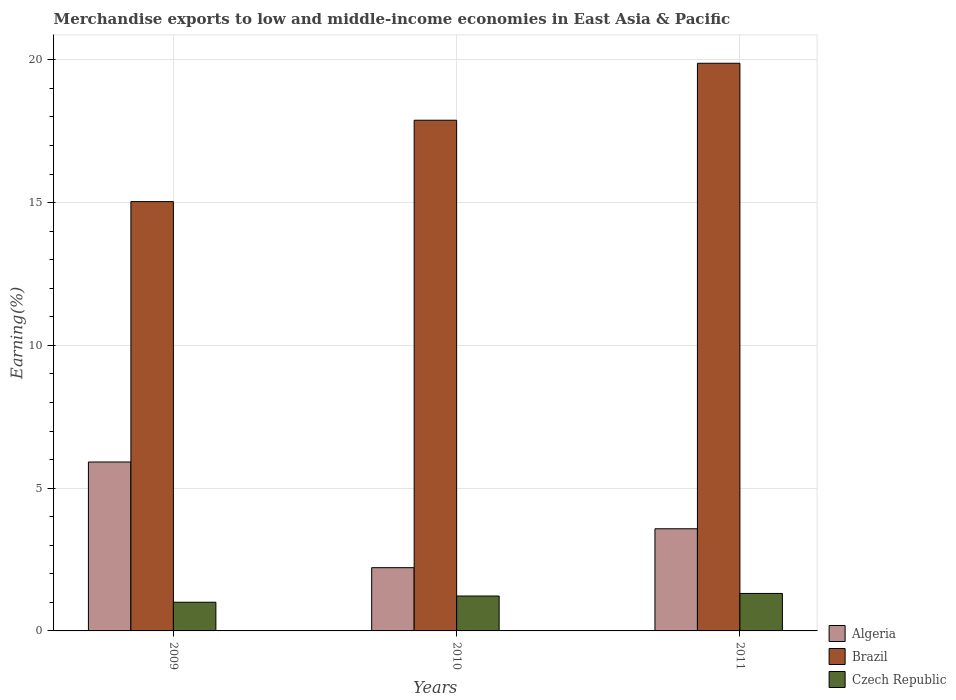How many different coloured bars are there?
Provide a succinct answer. 3. How many groups of bars are there?
Your answer should be compact. 3. Are the number of bars per tick equal to the number of legend labels?
Your answer should be compact. Yes. How many bars are there on the 2nd tick from the left?
Offer a very short reply. 3. How many bars are there on the 3rd tick from the right?
Your answer should be compact. 3. What is the label of the 1st group of bars from the left?
Keep it short and to the point. 2009. What is the percentage of amount earned from merchandise exports in Brazil in 2011?
Give a very brief answer. 19.88. Across all years, what is the maximum percentage of amount earned from merchandise exports in Algeria?
Your response must be concise. 5.92. Across all years, what is the minimum percentage of amount earned from merchandise exports in Czech Republic?
Your response must be concise. 1. In which year was the percentage of amount earned from merchandise exports in Czech Republic minimum?
Provide a succinct answer. 2009. What is the total percentage of amount earned from merchandise exports in Brazil in the graph?
Make the answer very short. 52.8. What is the difference between the percentage of amount earned from merchandise exports in Brazil in 2009 and that in 2010?
Your response must be concise. -2.85. What is the difference between the percentage of amount earned from merchandise exports in Brazil in 2011 and the percentage of amount earned from merchandise exports in Czech Republic in 2010?
Your response must be concise. 18.66. What is the average percentage of amount earned from merchandise exports in Brazil per year?
Your answer should be very brief. 17.6. In the year 2009, what is the difference between the percentage of amount earned from merchandise exports in Czech Republic and percentage of amount earned from merchandise exports in Brazil?
Keep it short and to the point. -14.03. In how many years, is the percentage of amount earned from merchandise exports in Czech Republic greater than 9 %?
Ensure brevity in your answer.  0. What is the ratio of the percentage of amount earned from merchandise exports in Czech Republic in 2009 to that in 2011?
Make the answer very short. 0.77. Is the percentage of amount earned from merchandise exports in Czech Republic in 2009 less than that in 2010?
Your response must be concise. Yes. Is the difference between the percentage of amount earned from merchandise exports in Czech Republic in 2009 and 2011 greater than the difference between the percentage of amount earned from merchandise exports in Brazil in 2009 and 2011?
Offer a very short reply. Yes. What is the difference between the highest and the second highest percentage of amount earned from merchandise exports in Czech Republic?
Ensure brevity in your answer.  0.09. What is the difference between the highest and the lowest percentage of amount earned from merchandise exports in Algeria?
Offer a very short reply. 3.7. What does the 2nd bar from the left in 2009 represents?
Keep it short and to the point. Brazil. What does the 3rd bar from the right in 2010 represents?
Give a very brief answer. Algeria. How many bars are there?
Give a very brief answer. 9. How many years are there in the graph?
Offer a terse response. 3. What is the difference between two consecutive major ticks on the Y-axis?
Keep it short and to the point. 5. Are the values on the major ticks of Y-axis written in scientific E-notation?
Your response must be concise. No. Does the graph contain grids?
Give a very brief answer. Yes. How many legend labels are there?
Your answer should be very brief. 3. What is the title of the graph?
Provide a succinct answer. Merchandise exports to low and middle-income economies in East Asia & Pacific. What is the label or title of the Y-axis?
Make the answer very short. Earning(%). What is the Earning(%) of Algeria in 2009?
Offer a terse response. 5.92. What is the Earning(%) in Brazil in 2009?
Your answer should be compact. 15.04. What is the Earning(%) in Czech Republic in 2009?
Provide a succinct answer. 1. What is the Earning(%) in Algeria in 2010?
Give a very brief answer. 2.21. What is the Earning(%) of Brazil in 2010?
Offer a terse response. 17.89. What is the Earning(%) in Czech Republic in 2010?
Your answer should be compact. 1.22. What is the Earning(%) in Algeria in 2011?
Provide a succinct answer. 3.58. What is the Earning(%) in Brazil in 2011?
Your answer should be compact. 19.88. What is the Earning(%) in Czech Republic in 2011?
Make the answer very short. 1.31. Across all years, what is the maximum Earning(%) in Algeria?
Your answer should be compact. 5.92. Across all years, what is the maximum Earning(%) of Brazil?
Offer a very short reply. 19.88. Across all years, what is the maximum Earning(%) of Czech Republic?
Your response must be concise. 1.31. Across all years, what is the minimum Earning(%) in Algeria?
Offer a very short reply. 2.21. Across all years, what is the minimum Earning(%) of Brazil?
Give a very brief answer. 15.04. Across all years, what is the minimum Earning(%) in Czech Republic?
Offer a terse response. 1. What is the total Earning(%) of Algeria in the graph?
Offer a terse response. 11.71. What is the total Earning(%) in Brazil in the graph?
Make the answer very short. 52.8. What is the total Earning(%) of Czech Republic in the graph?
Provide a succinct answer. 3.54. What is the difference between the Earning(%) of Algeria in 2009 and that in 2010?
Offer a very short reply. 3.7. What is the difference between the Earning(%) in Brazil in 2009 and that in 2010?
Your response must be concise. -2.85. What is the difference between the Earning(%) of Czech Republic in 2009 and that in 2010?
Give a very brief answer. -0.22. What is the difference between the Earning(%) of Algeria in 2009 and that in 2011?
Your response must be concise. 2.34. What is the difference between the Earning(%) in Brazil in 2009 and that in 2011?
Provide a succinct answer. -4.85. What is the difference between the Earning(%) of Czech Republic in 2009 and that in 2011?
Offer a very short reply. -0.31. What is the difference between the Earning(%) of Algeria in 2010 and that in 2011?
Your response must be concise. -1.36. What is the difference between the Earning(%) in Brazil in 2010 and that in 2011?
Ensure brevity in your answer.  -2. What is the difference between the Earning(%) of Czech Republic in 2010 and that in 2011?
Keep it short and to the point. -0.09. What is the difference between the Earning(%) of Algeria in 2009 and the Earning(%) of Brazil in 2010?
Make the answer very short. -11.97. What is the difference between the Earning(%) of Algeria in 2009 and the Earning(%) of Czech Republic in 2010?
Your response must be concise. 4.69. What is the difference between the Earning(%) of Brazil in 2009 and the Earning(%) of Czech Republic in 2010?
Offer a very short reply. 13.81. What is the difference between the Earning(%) in Algeria in 2009 and the Earning(%) in Brazil in 2011?
Provide a short and direct response. -13.96. What is the difference between the Earning(%) in Algeria in 2009 and the Earning(%) in Czech Republic in 2011?
Provide a short and direct response. 4.6. What is the difference between the Earning(%) in Brazil in 2009 and the Earning(%) in Czech Republic in 2011?
Your answer should be very brief. 13.72. What is the difference between the Earning(%) of Algeria in 2010 and the Earning(%) of Brazil in 2011?
Give a very brief answer. -17.67. What is the difference between the Earning(%) of Algeria in 2010 and the Earning(%) of Czech Republic in 2011?
Keep it short and to the point. 0.9. What is the difference between the Earning(%) of Brazil in 2010 and the Earning(%) of Czech Republic in 2011?
Provide a succinct answer. 16.57. What is the average Earning(%) of Algeria per year?
Make the answer very short. 3.9. What is the average Earning(%) in Brazil per year?
Your response must be concise. 17.6. What is the average Earning(%) in Czech Republic per year?
Your answer should be compact. 1.18. In the year 2009, what is the difference between the Earning(%) in Algeria and Earning(%) in Brazil?
Offer a terse response. -9.12. In the year 2009, what is the difference between the Earning(%) of Algeria and Earning(%) of Czech Republic?
Offer a very short reply. 4.91. In the year 2009, what is the difference between the Earning(%) in Brazil and Earning(%) in Czech Republic?
Your response must be concise. 14.03. In the year 2010, what is the difference between the Earning(%) in Algeria and Earning(%) in Brazil?
Make the answer very short. -15.67. In the year 2010, what is the difference between the Earning(%) in Brazil and Earning(%) in Czech Republic?
Make the answer very short. 16.66. In the year 2011, what is the difference between the Earning(%) in Algeria and Earning(%) in Brazil?
Make the answer very short. -16.3. In the year 2011, what is the difference between the Earning(%) of Algeria and Earning(%) of Czech Republic?
Make the answer very short. 2.26. In the year 2011, what is the difference between the Earning(%) of Brazil and Earning(%) of Czech Republic?
Offer a terse response. 18.57. What is the ratio of the Earning(%) of Algeria in 2009 to that in 2010?
Offer a terse response. 2.67. What is the ratio of the Earning(%) in Brazil in 2009 to that in 2010?
Make the answer very short. 0.84. What is the ratio of the Earning(%) of Czech Republic in 2009 to that in 2010?
Your answer should be very brief. 0.82. What is the ratio of the Earning(%) in Algeria in 2009 to that in 2011?
Offer a terse response. 1.65. What is the ratio of the Earning(%) of Brazil in 2009 to that in 2011?
Ensure brevity in your answer.  0.76. What is the ratio of the Earning(%) in Czech Republic in 2009 to that in 2011?
Offer a terse response. 0.77. What is the ratio of the Earning(%) in Algeria in 2010 to that in 2011?
Offer a terse response. 0.62. What is the ratio of the Earning(%) in Brazil in 2010 to that in 2011?
Make the answer very short. 0.9. What is the ratio of the Earning(%) of Czech Republic in 2010 to that in 2011?
Ensure brevity in your answer.  0.93. What is the difference between the highest and the second highest Earning(%) of Algeria?
Ensure brevity in your answer.  2.34. What is the difference between the highest and the second highest Earning(%) of Brazil?
Offer a very short reply. 2. What is the difference between the highest and the second highest Earning(%) in Czech Republic?
Your answer should be compact. 0.09. What is the difference between the highest and the lowest Earning(%) in Algeria?
Your response must be concise. 3.7. What is the difference between the highest and the lowest Earning(%) in Brazil?
Offer a terse response. 4.85. What is the difference between the highest and the lowest Earning(%) in Czech Republic?
Provide a succinct answer. 0.31. 